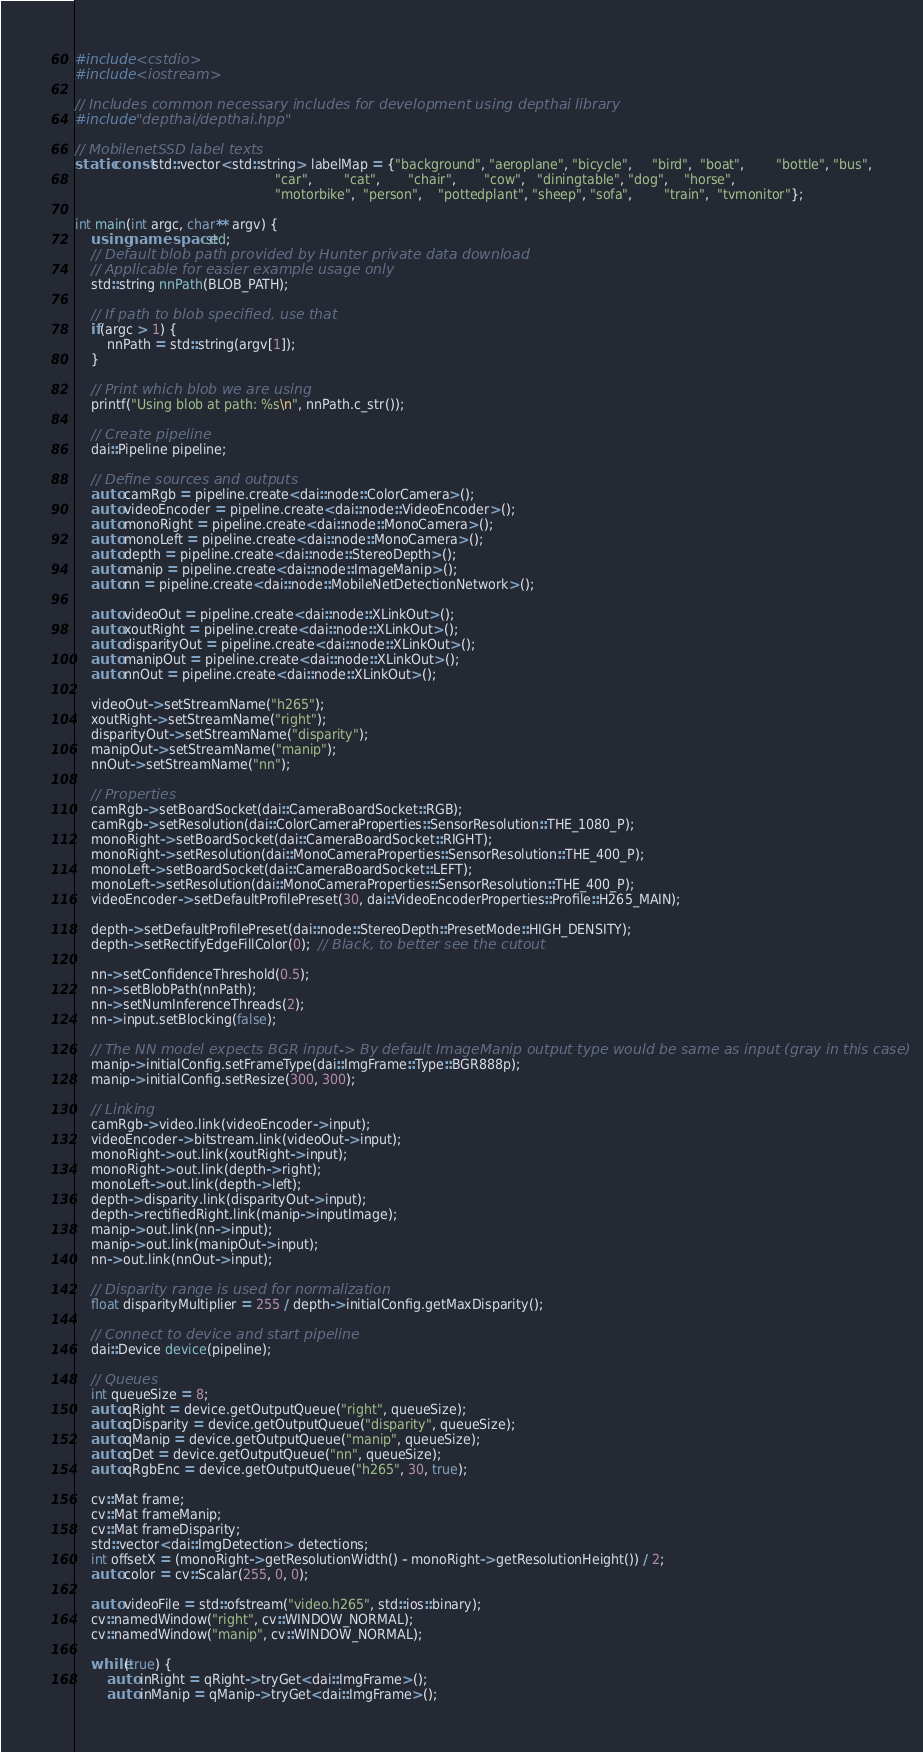<code> <loc_0><loc_0><loc_500><loc_500><_C++_>#include <cstdio>
#include <iostream>

// Includes common necessary includes for development using depthai library
#include "depthai/depthai.hpp"

// MobilenetSSD label texts
static const std::vector<std::string> labelMap = {"background", "aeroplane", "bicycle",     "bird",  "boat",        "bottle", "bus",
                                                  "car",        "cat",       "chair",       "cow",   "diningtable", "dog",    "horse",
                                                  "motorbike",  "person",    "pottedplant", "sheep", "sofa",        "train",  "tvmonitor"};

int main(int argc, char** argv) {
    using namespace std;
    // Default blob path provided by Hunter private data download
    // Applicable for easier example usage only
    std::string nnPath(BLOB_PATH);

    // If path to blob specified, use that
    if(argc > 1) {
        nnPath = std::string(argv[1]);
    }

    // Print which blob we are using
    printf("Using blob at path: %s\n", nnPath.c_str());

    // Create pipeline
    dai::Pipeline pipeline;

    // Define sources and outputs
    auto camRgb = pipeline.create<dai::node::ColorCamera>();
    auto videoEncoder = pipeline.create<dai::node::VideoEncoder>();
    auto monoRight = pipeline.create<dai::node::MonoCamera>();
    auto monoLeft = pipeline.create<dai::node::MonoCamera>();
    auto depth = pipeline.create<dai::node::StereoDepth>();
    auto manip = pipeline.create<dai::node::ImageManip>();
    auto nn = pipeline.create<dai::node::MobileNetDetectionNetwork>();

    auto videoOut = pipeline.create<dai::node::XLinkOut>();
    auto xoutRight = pipeline.create<dai::node::XLinkOut>();
    auto disparityOut = pipeline.create<dai::node::XLinkOut>();
    auto manipOut = pipeline.create<dai::node::XLinkOut>();
    auto nnOut = pipeline.create<dai::node::XLinkOut>();

    videoOut->setStreamName("h265");
    xoutRight->setStreamName("right");
    disparityOut->setStreamName("disparity");
    manipOut->setStreamName("manip");
    nnOut->setStreamName("nn");

    // Properties
    camRgb->setBoardSocket(dai::CameraBoardSocket::RGB);
    camRgb->setResolution(dai::ColorCameraProperties::SensorResolution::THE_1080_P);
    monoRight->setBoardSocket(dai::CameraBoardSocket::RIGHT);
    monoRight->setResolution(dai::MonoCameraProperties::SensorResolution::THE_400_P);
    monoLeft->setBoardSocket(dai::CameraBoardSocket::LEFT);
    monoLeft->setResolution(dai::MonoCameraProperties::SensorResolution::THE_400_P);
    videoEncoder->setDefaultProfilePreset(30, dai::VideoEncoderProperties::Profile::H265_MAIN);

    depth->setDefaultProfilePreset(dai::node::StereoDepth::PresetMode::HIGH_DENSITY);
    depth->setRectifyEdgeFillColor(0);  // Black, to better see the cutout

    nn->setConfidenceThreshold(0.5);
    nn->setBlobPath(nnPath);
    nn->setNumInferenceThreads(2);
    nn->input.setBlocking(false);

    // The NN model expects BGR input-> By default ImageManip output type would be same as input (gray in this case)
    manip->initialConfig.setFrameType(dai::ImgFrame::Type::BGR888p);
    manip->initialConfig.setResize(300, 300);

    // Linking
    camRgb->video.link(videoEncoder->input);
    videoEncoder->bitstream.link(videoOut->input);
    monoRight->out.link(xoutRight->input);
    monoRight->out.link(depth->right);
    monoLeft->out.link(depth->left);
    depth->disparity.link(disparityOut->input);
    depth->rectifiedRight.link(manip->inputImage);
    manip->out.link(nn->input);
    manip->out.link(manipOut->input);
    nn->out.link(nnOut->input);

    // Disparity range is used for normalization
    float disparityMultiplier = 255 / depth->initialConfig.getMaxDisparity();

    // Connect to device and start pipeline
    dai::Device device(pipeline);

    // Queues
    int queueSize = 8;
    auto qRight = device.getOutputQueue("right", queueSize);
    auto qDisparity = device.getOutputQueue("disparity", queueSize);
    auto qManip = device.getOutputQueue("manip", queueSize);
    auto qDet = device.getOutputQueue("nn", queueSize);
    auto qRgbEnc = device.getOutputQueue("h265", 30, true);

    cv::Mat frame;
    cv::Mat frameManip;
    cv::Mat frameDisparity;
    std::vector<dai::ImgDetection> detections;
    int offsetX = (monoRight->getResolutionWidth() - monoRight->getResolutionHeight()) / 2;
    auto color = cv::Scalar(255, 0, 0);

    auto videoFile = std::ofstream("video.h265", std::ios::binary);
    cv::namedWindow("right", cv::WINDOW_NORMAL);
    cv::namedWindow("manip", cv::WINDOW_NORMAL);

    while(true) {
        auto inRight = qRight->tryGet<dai::ImgFrame>();
        auto inManip = qManip->tryGet<dai::ImgFrame>();</code> 